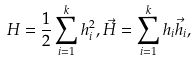<formula> <loc_0><loc_0><loc_500><loc_500>H = \frac { 1 } { 2 } \sum _ { i = 1 } ^ { k } h _ { i } ^ { 2 } , \vec { H } = \sum _ { i = 1 } ^ { k } h _ { i } \vec { h } _ { i } ,</formula> 